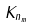Convert formula to latex. <formula><loc_0><loc_0><loc_500><loc_500>K _ { n _ { m } }</formula> 